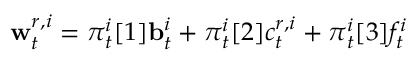<formula> <loc_0><loc_0><loc_500><loc_500>w _ { t } ^ { r , i } = { \pi } _ { t } ^ { i } [ 1 ] b _ { t } ^ { i } + { \pi } _ { t } ^ { i } [ 2 ] c _ { t } ^ { r , i } + { \pi } _ { t } ^ { i } [ 3 ] f _ { t } ^ { i }</formula> 